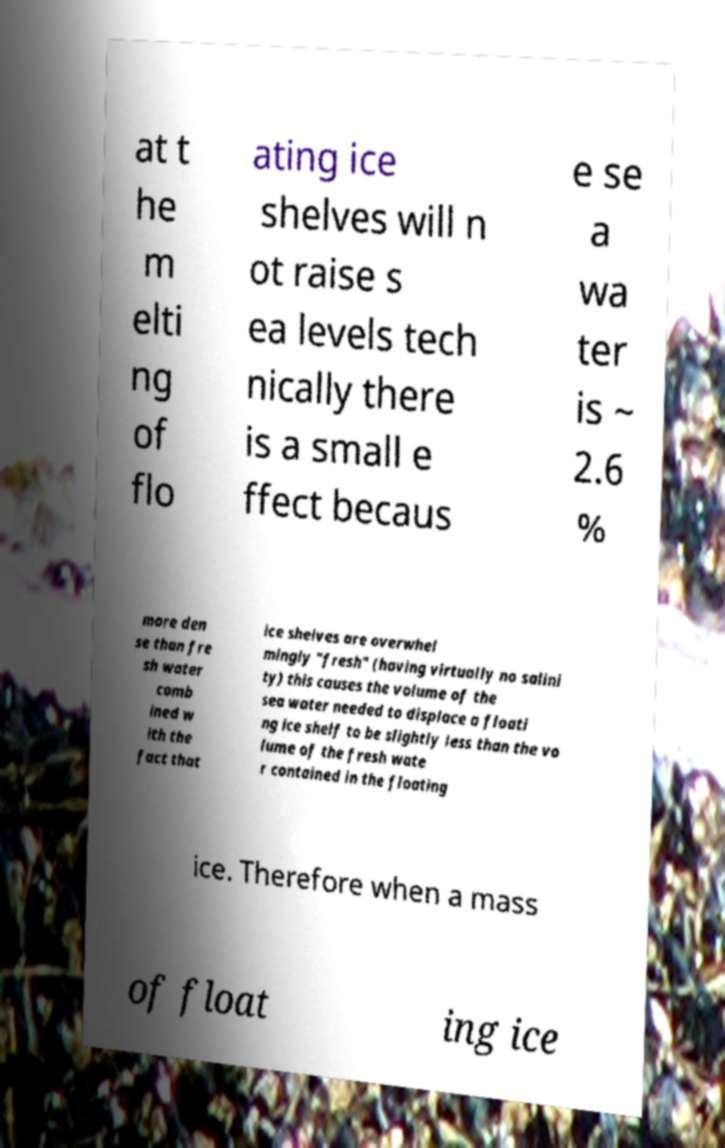Please read and relay the text visible in this image. What does it say? at t he m elti ng of flo ating ice shelves will n ot raise s ea levels tech nically there is a small e ffect becaus e se a wa ter is ~ 2.6 % more den se than fre sh water comb ined w ith the fact that ice shelves are overwhel mingly "fresh" (having virtually no salini ty) this causes the volume of the sea water needed to displace a floati ng ice shelf to be slightly less than the vo lume of the fresh wate r contained in the floating ice. Therefore when a mass of float ing ice 